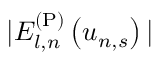Convert formula to latex. <formula><loc_0><loc_0><loc_500><loc_500>| E _ { l , n } ^ { ( P ) } \left ( u _ { n , s } \right ) |</formula> 